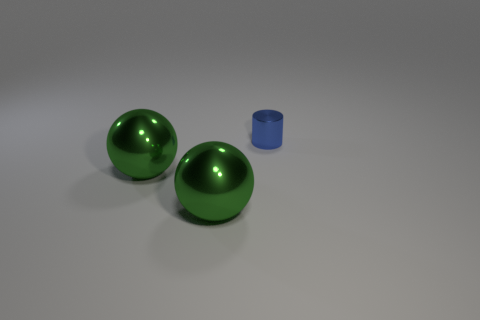What number of other things are there of the same size as the blue thing?
Provide a succinct answer. 0. How many other objects are the same shape as the small metal thing?
Provide a short and direct response. 0. What number of cylinders are tiny things or large green objects?
Your response must be concise. 1. What number of brown things are either large balls or metal objects?
Your answer should be very brief. 0. Are there any tiny cylinders of the same color as the tiny metallic object?
Provide a short and direct response. No. Are there any yellow rubber things?
Make the answer very short. No. How many blue things have the same size as the cylinder?
Provide a succinct answer. 0. Is the number of big objects on the left side of the tiny shiny cylinder the same as the number of green spheres?
Provide a short and direct response. Yes. How many other blue metallic objects are the same shape as the small blue thing?
Keep it short and to the point. 0. Is the number of shiny cylinders that are behind the small blue metal thing greater than the number of large metal balls?
Offer a very short reply. No. 